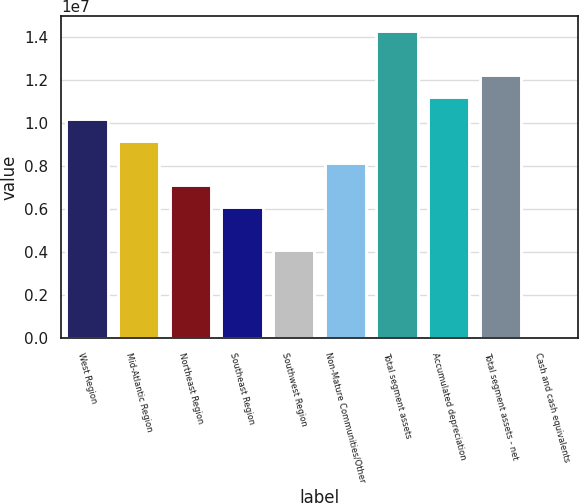Convert chart. <chart><loc_0><loc_0><loc_500><loc_500><bar_chart><fcel>West Region<fcel>Mid-Atlantic Region<fcel>Northeast Region<fcel>Southeast Region<fcel>Southwest Region<fcel>Non-Mature Communities/Other<fcel>Total segment assets<fcel>Accumulated depreciation<fcel>Total segment assets - net<fcel>Cash and cash equivalents<nl><fcel>1.01772e+07<fcel>9.15969e+06<fcel>7.12466e+06<fcel>6.10714e+06<fcel>4.07211e+06<fcel>8.14217e+06<fcel>1.42473e+07<fcel>1.11947e+07<fcel>1.22122e+07<fcel>2038<nl></chart> 